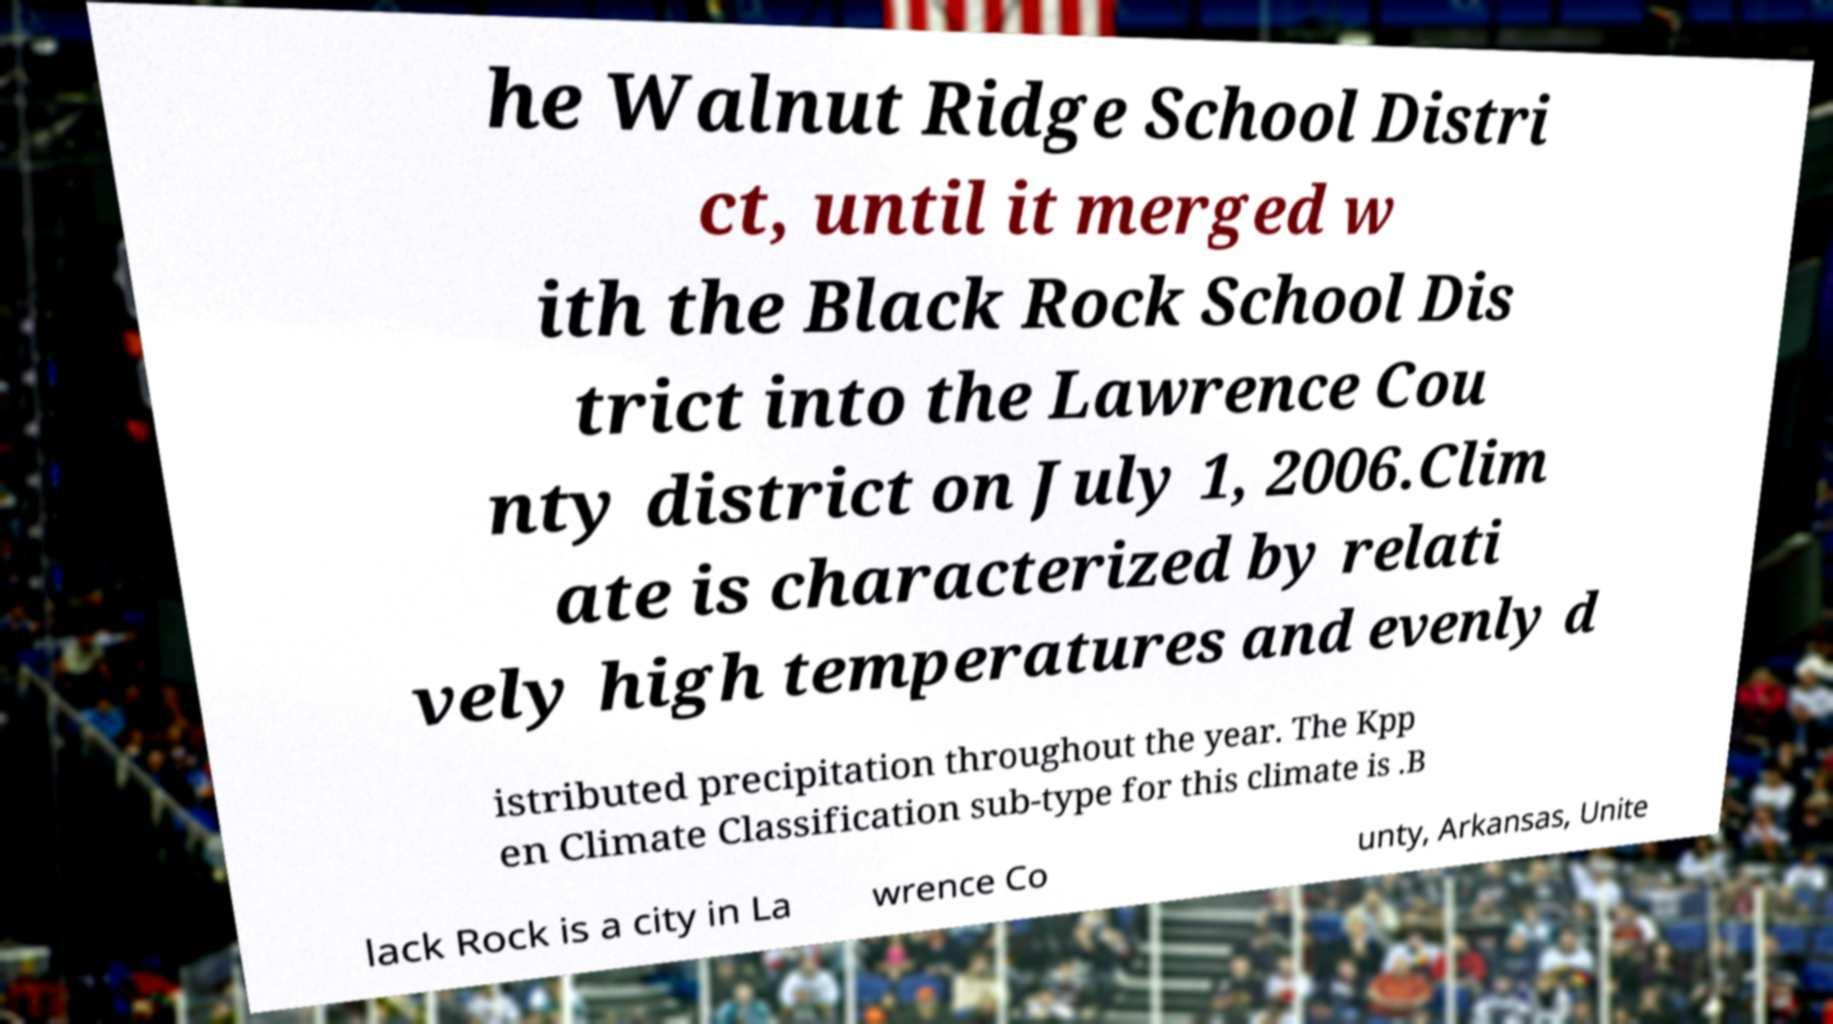Can you accurately transcribe the text from the provided image for me? he Walnut Ridge School Distri ct, until it merged w ith the Black Rock School Dis trict into the Lawrence Cou nty district on July 1, 2006.Clim ate is characterized by relati vely high temperatures and evenly d istributed precipitation throughout the year. The Kpp en Climate Classification sub-type for this climate is .B lack Rock is a city in La wrence Co unty, Arkansas, Unite 